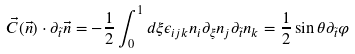Convert formula to latex. <formula><loc_0><loc_0><loc_500><loc_500>\vec { C } ( \vec { n } ) \cdot \partial _ { \tilde { t } } \vec { n } = - \frac { 1 } { 2 } \int _ { 0 } ^ { 1 } d \xi \epsilon _ { i j k } n _ { i } \partial _ { \xi } n _ { j } \partial _ { \tilde { t } } n _ { k } = \frac { 1 } { 2 } \sin \theta \partial _ { \tilde { t } } \varphi</formula> 